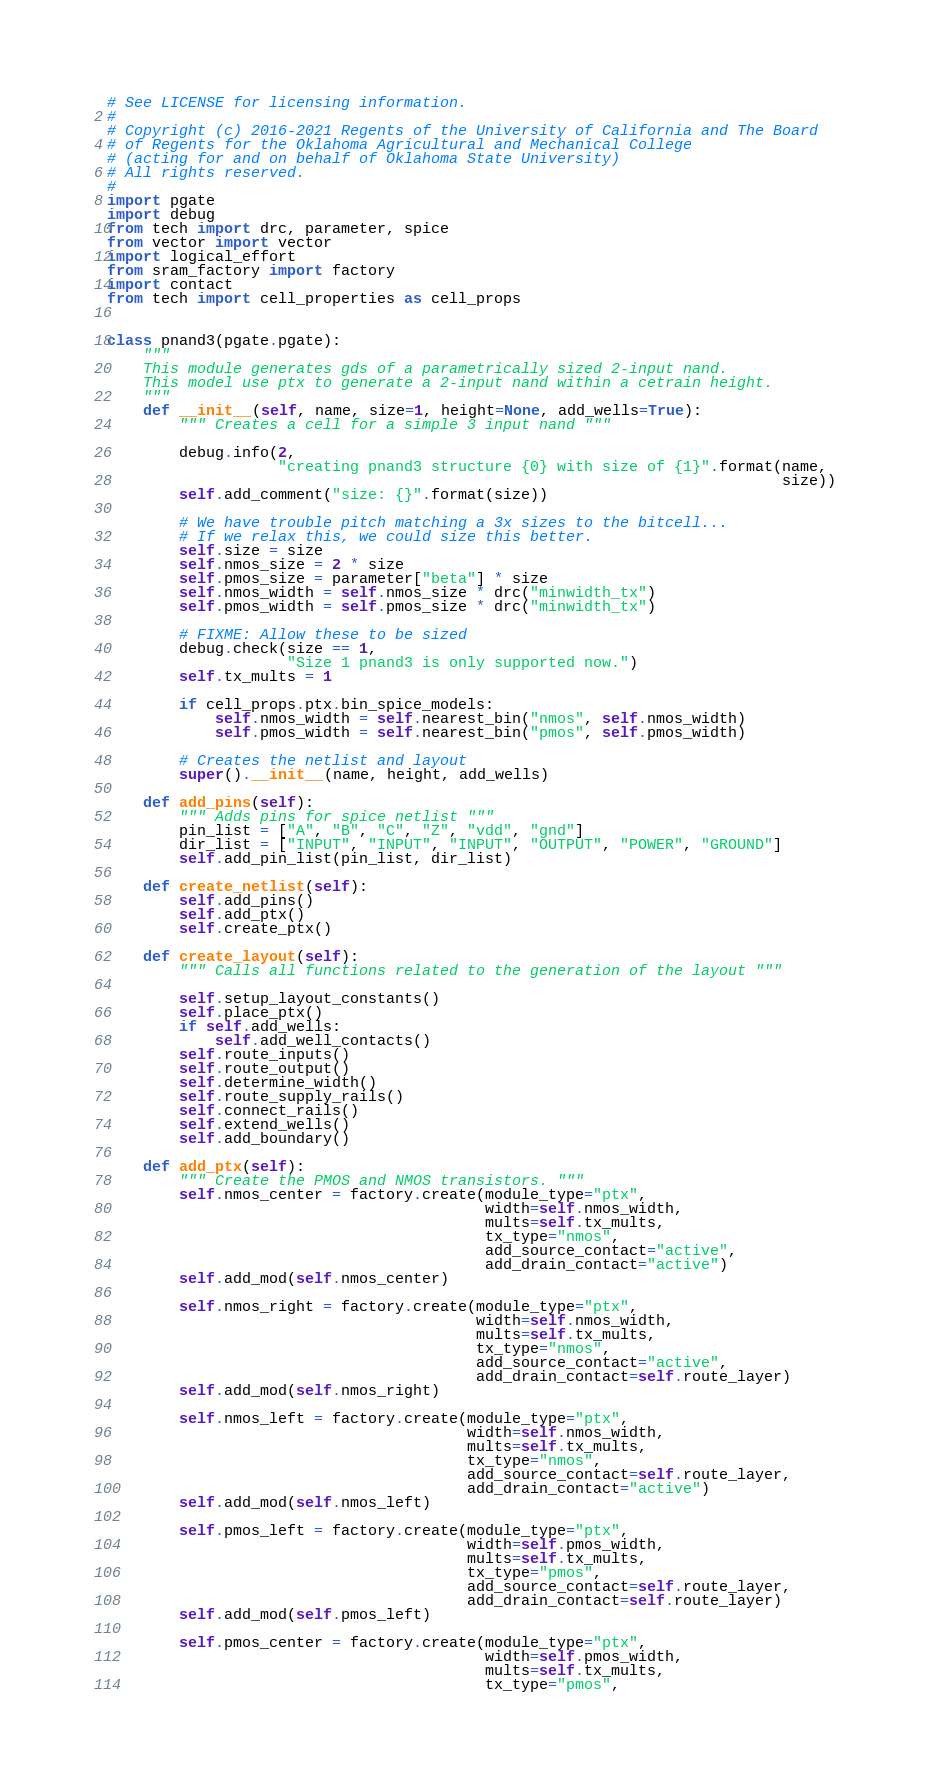Convert code to text. <code><loc_0><loc_0><loc_500><loc_500><_Python_># See LICENSE for licensing information.
#
# Copyright (c) 2016-2021 Regents of the University of California and The Board
# of Regents for the Oklahoma Agricultural and Mechanical College
# (acting for and on behalf of Oklahoma State University)
# All rights reserved.
#
import pgate
import debug
from tech import drc, parameter, spice
from vector import vector
import logical_effort
from sram_factory import factory
import contact
from tech import cell_properties as cell_props


class pnand3(pgate.pgate):
    """
    This module generates gds of a parametrically sized 2-input nand.
    This model use ptx to generate a 2-input nand within a cetrain height.
    """
    def __init__(self, name, size=1, height=None, add_wells=True):
        """ Creates a cell for a simple 3 input nand """

        debug.info(2,
                   "creating pnand3 structure {0} with size of {1}".format(name,
                                                                           size))
        self.add_comment("size: {}".format(size))

        # We have trouble pitch matching a 3x sizes to the bitcell...
        # If we relax this, we could size this better.
        self.size = size
        self.nmos_size = 2 * size
        self.pmos_size = parameter["beta"] * size
        self.nmos_width = self.nmos_size * drc("minwidth_tx")
        self.pmos_width = self.pmos_size * drc("minwidth_tx")

        # FIXME: Allow these to be sized
        debug.check(size == 1,
                    "Size 1 pnand3 is only supported now.")
        self.tx_mults = 1

        if cell_props.ptx.bin_spice_models:
            self.nmos_width = self.nearest_bin("nmos", self.nmos_width)
            self.pmos_width = self.nearest_bin("pmos", self.pmos_width)

        # Creates the netlist and layout
        super().__init__(name, height, add_wells)

    def add_pins(self):
        """ Adds pins for spice netlist """
        pin_list = ["A", "B", "C", "Z", "vdd", "gnd"]
        dir_list = ["INPUT", "INPUT", "INPUT", "OUTPUT", "POWER", "GROUND"]
        self.add_pin_list(pin_list, dir_list)

    def create_netlist(self):
        self.add_pins()
        self.add_ptx()
        self.create_ptx()

    def create_layout(self):
        """ Calls all functions related to the generation of the layout """

        self.setup_layout_constants()
        self.place_ptx()
        if self.add_wells:
            self.add_well_contacts()
        self.route_inputs()
        self.route_output()
        self.determine_width()
        self.route_supply_rails()
        self.connect_rails()
        self.extend_wells()
        self.add_boundary()

    def add_ptx(self):
        """ Create the PMOS and NMOS transistors. """
        self.nmos_center = factory.create(module_type="ptx",
                                          width=self.nmos_width,
                                          mults=self.tx_mults,
                                          tx_type="nmos",
                                          add_source_contact="active",
                                          add_drain_contact="active")
        self.add_mod(self.nmos_center)

        self.nmos_right = factory.create(module_type="ptx",
                                         width=self.nmos_width,
                                         mults=self.tx_mults,
                                         tx_type="nmos",
                                         add_source_contact="active",
                                         add_drain_contact=self.route_layer)
        self.add_mod(self.nmos_right)

        self.nmos_left = factory.create(module_type="ptx",
                                        width=self.nmos_width,
                                        mults=self.tx_mults,
                                        tx_type="nmos",
                                        add_source_contact=self.route_layer,
                                        add_drain_contact="active")
        self.add_mod(self.nmos_left)

        self.pmos_left = factory.create(module_type="ptx",
                                        width=self.pmos_width,
                                        mults=self.tx_mults,
                                        tx_type="pmos",
                                        add_source_contact=self.route_layer,
                                        add_drain_contact=self.route_layer)
        self.add_mod(self.pmos_left)

        self.pmos_center = factory.create(module_type="ptx",
                                          width=self.pmos_width,
                                          mults=self.tx_mults,
                                          tx_type="pmos",</code> 